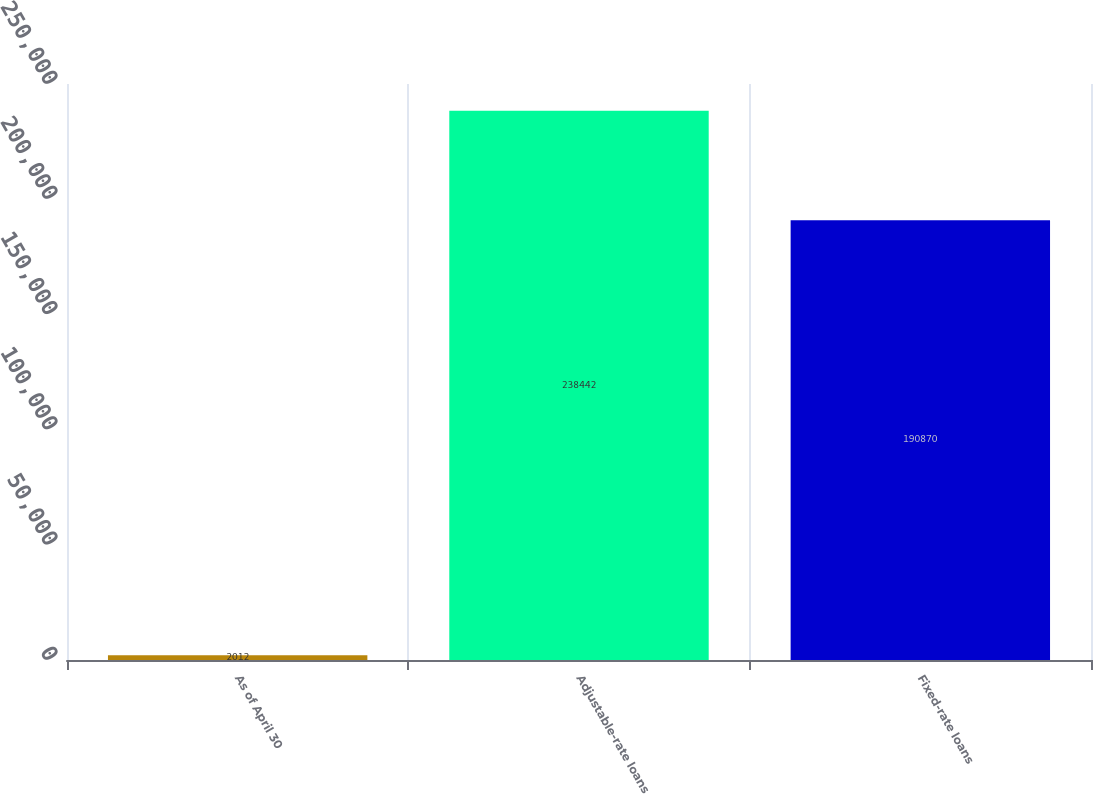<chart> <loc_0><loc_0><loc_500><loc_500><bar_chart><fcel>As of April 30<fcel>Adjustable-rate loans<fcel>Fixed-rate loans<nl><fcel>2012<fcel>238442<fcel>190870<nl></chart> 